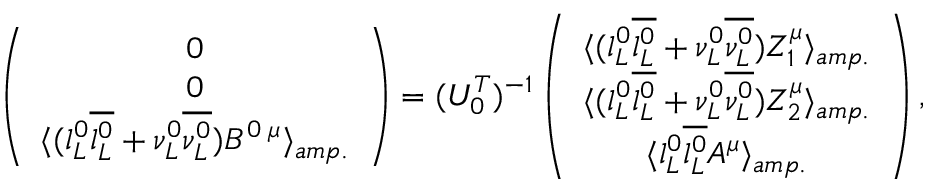Convert formula to latex. <formula><loc_0><loc_0><loc_500><loc_500>\left ( \begin{array} { c } { 0 } \\ { 0 } \\ { { \langle ( l _ { L } ^ { 0 } \overline { { { l _ { L } ^ { 0 } } } } + \nu _ { L } ^ { 0 } \overline { { { \nu _ { L } ^ { 0 } } } } ) { B } ^ { 0 \, \mu } \rangle _ { a m p . } } } \end{array} \right ) = ( U _ { 0 } ^ { T } ) ^ { - 1 } \left ( \begin{array} { c } { { \langle ( l _ { L } ^ { 0 } \overline { { { l _ { L } ^ { 0 } } } } + \nu _ { L } ^ { 0 } \overline { { { \nu _ { L } ^ { 0 } } } } ) { Z } _ { 1 } ^ { \mu } \rangle _ { a m p . } } } \\ { { \langle ( l _ { L } ^ { 0 } \overline { { { l _ { L } ^ { 0 } } } } + \nu _ { L } ^ { 0 } \overline { { { \nu _ { L } ^ { 0 } } } } ) { Z } _ { 2 } ^ { \mu } \rangle _ { a m p . } } } \\ { { \langle l _ { L } ^ { 0 } \overline { { { l _ { L } ^ { 0 } } } } { A } ^ { \mu } \rangle _ { a m p . } } } \end{array} \right ) ,</formula> 